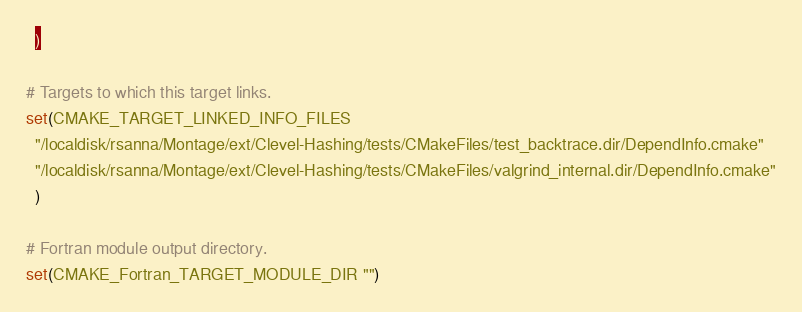<code> <loc_0><loc_0><loc_500><loc_500><_CMake_>  )

# Targets to which this target links.
set(CMAKE_TARGET_LINKED_INFO_FILES
  "/localdisk/rsanna/Montage/ext/Clevel-Hashing/tests/CMakeFiles/test_backtrace.dir/DependInfo.cmake"
  "/localdisk/rsanna/Montage/ext/Clevel-Hashing/tests/CMakeFiles/valgrind_internal.dir/DependInfo.cmake"
  )

# Fortran module output directory.
set(CMAKE_Fortran_TARGET_MODULE_DIR "")
</code> 